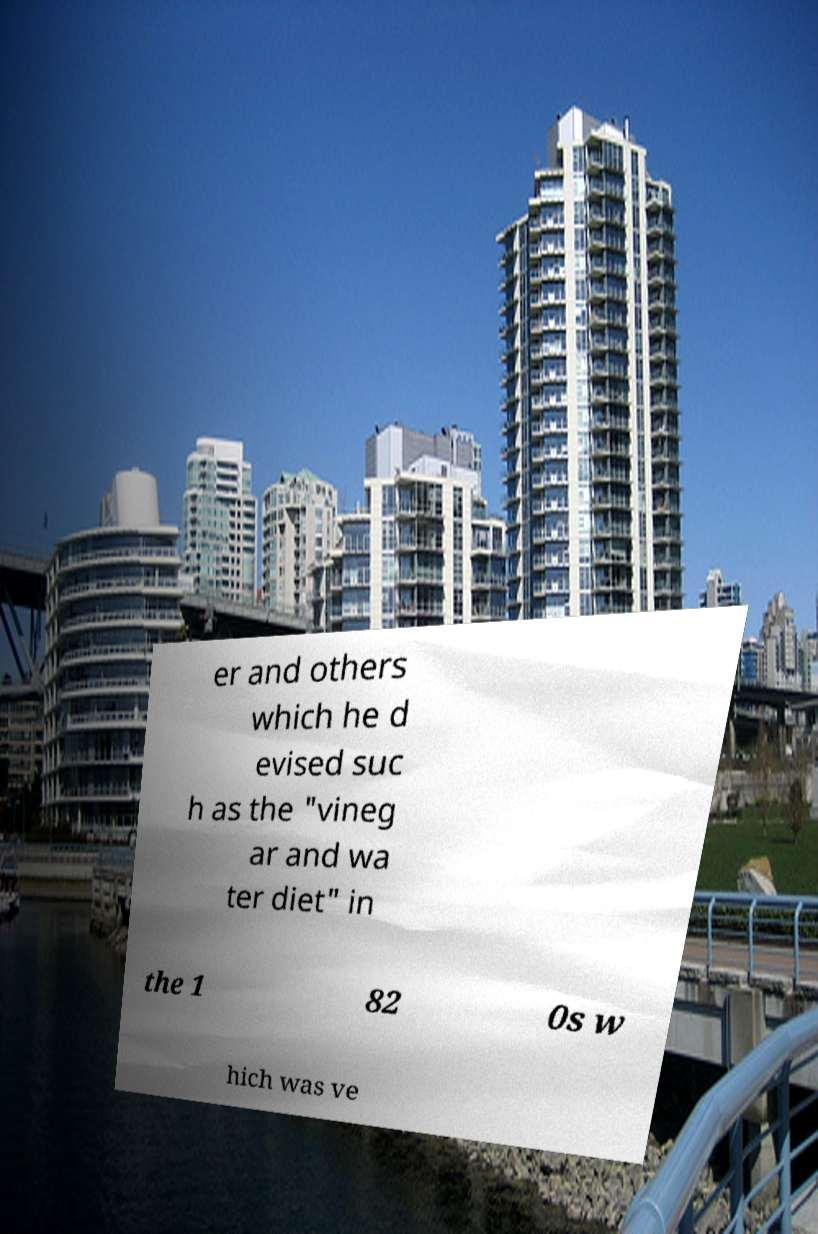What messages or text are displayed in this image? I need them in a readable, typed format. er and others which he d evised suc h as the "vineg ar and wa ter diet" in the 1 82 0s w hich was ve 